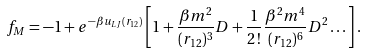<formula> <loc_0><loc_0><loc_500><loc_500>f _ { M } = - 1 + e ^ { - { \beta } u _ { L J } ( r _ { 1 2 } ) } \left [ 1 + \frac { { \beta } m ^ { 2 } } { ( r _ { 1 2 } ) ^ { 3 } } D + \frac { 1 } { 2 \, ! } \frac { { \beta } ^ { 2 } m ^ { 4 } } { ( r _ { 1 2 } ) ^ { 6 } } D ^ { 2 } \dots \right ] .</formula> 